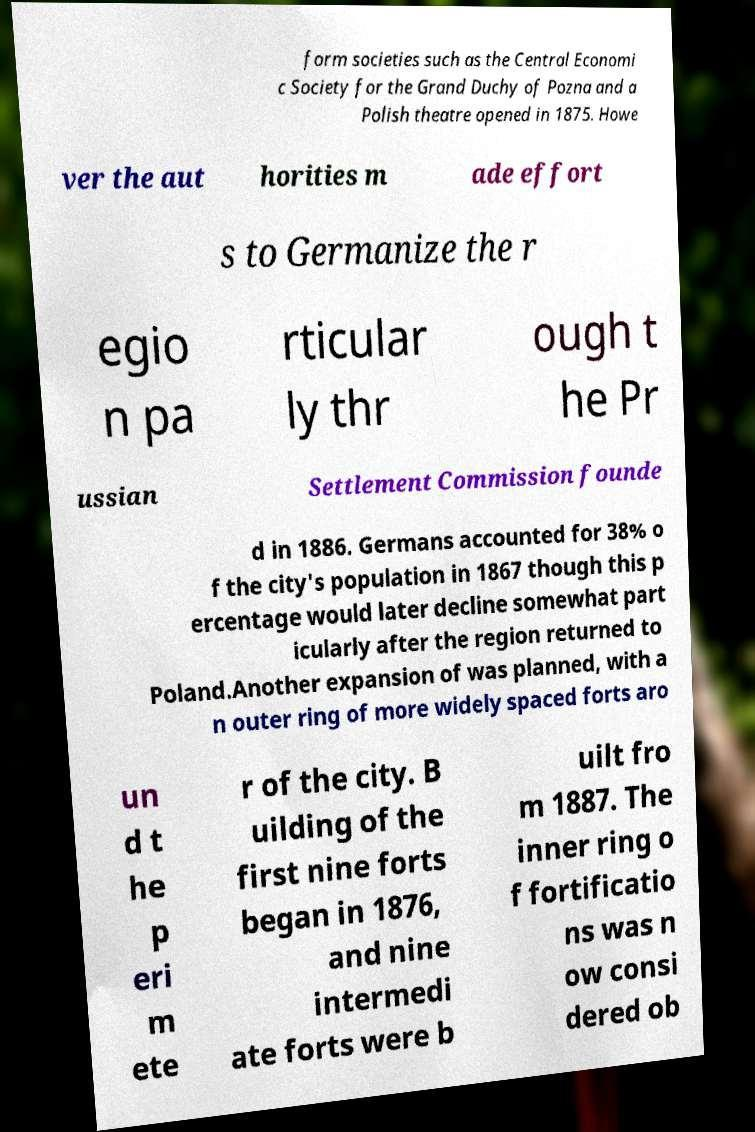I need the written content from this picture converted into text. Can you do that? form societies such as the Central Economi c Society for the Grand Duchy of Pozna and a Polish theatre opened in 1875. Howe ver the aut horities m ade effort s to Germanize the r egio n pa rticular ly thr ough t he Pr ussian Settlement Commission founde d in 1886. Germans accounted for 38% o f the city's population in 1867 though this p ercentage would later decline somewhat part icularly after the region returned to Poland.Another expansion of was planned, with a n outer ring of more widely spaced forts aro un d t he p eri m ete r of the city. B uilding of the first nine forts began in 1876, and nine intermedi ate forts were b uilt fro m 1887. The inner ring o f fortificatio ns was n ow consi dered ob 